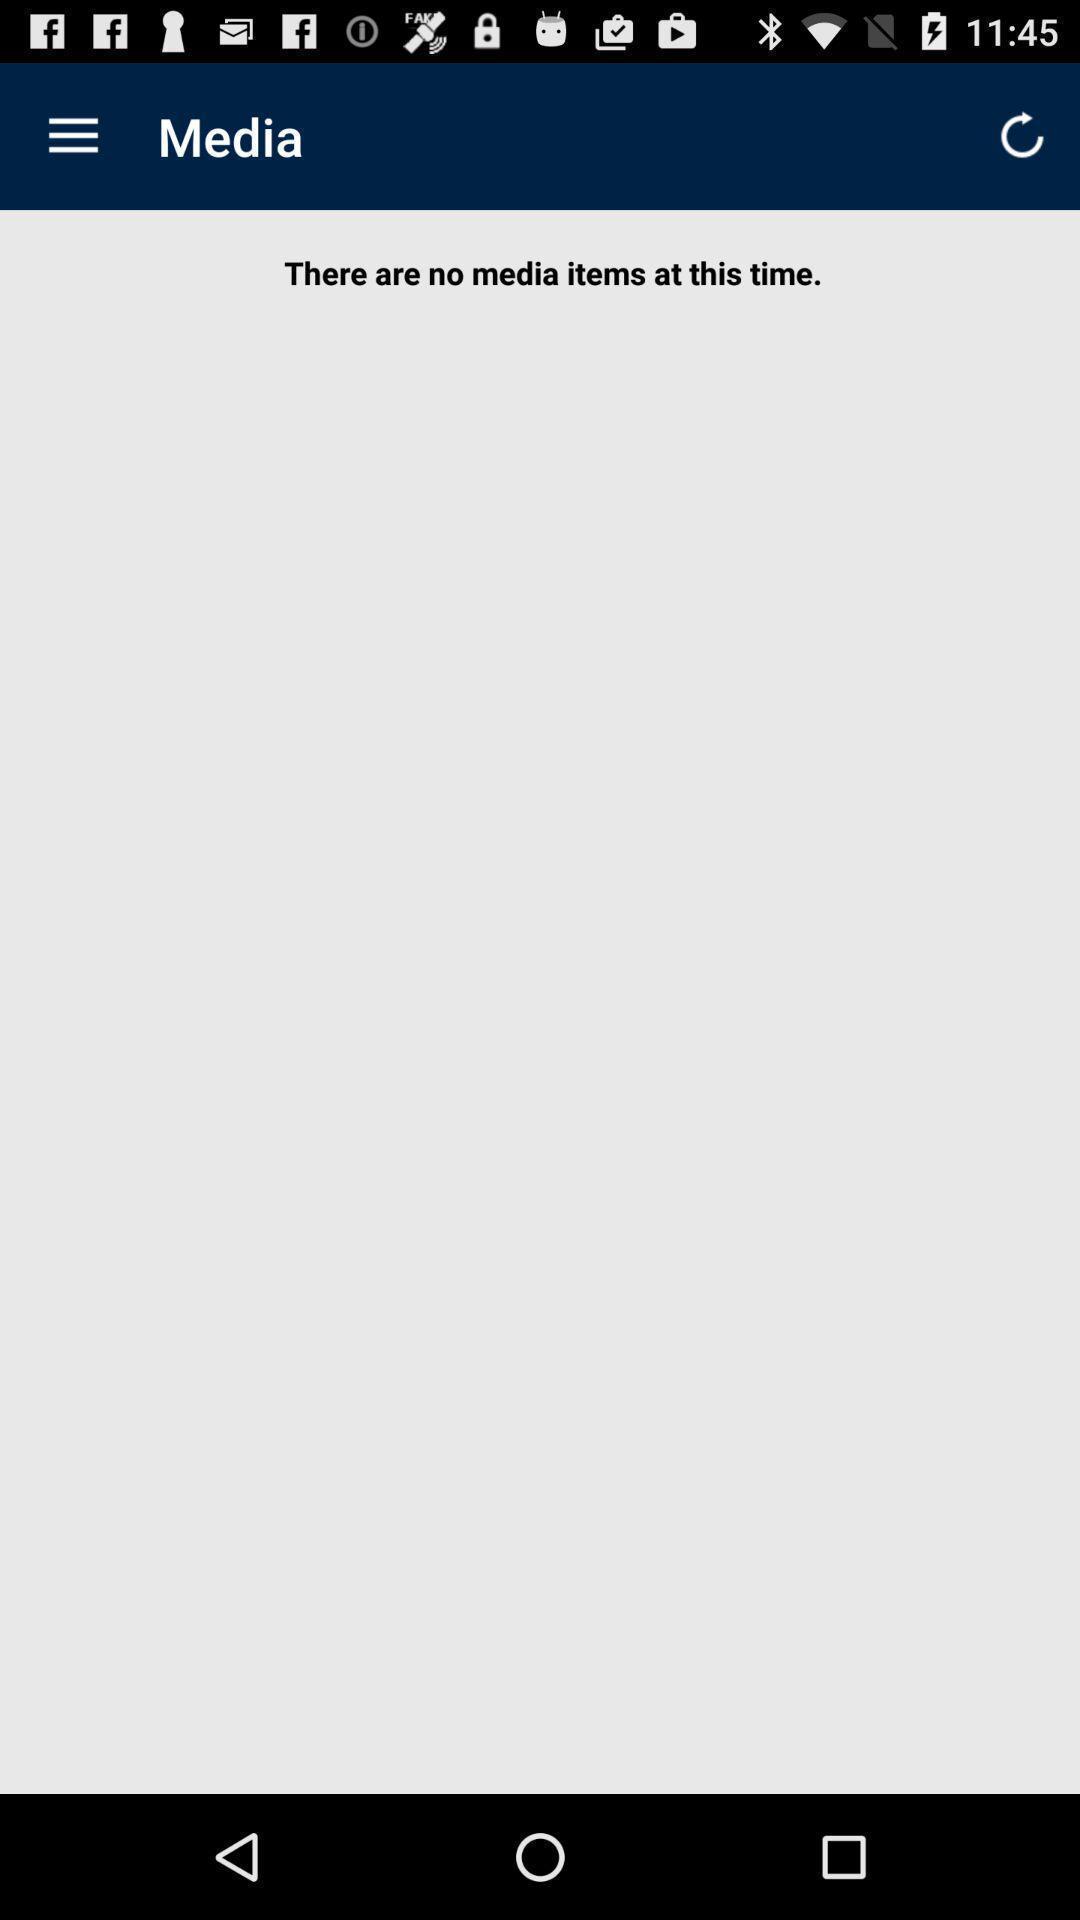Please provide a description for this image. Screen showing media page. 